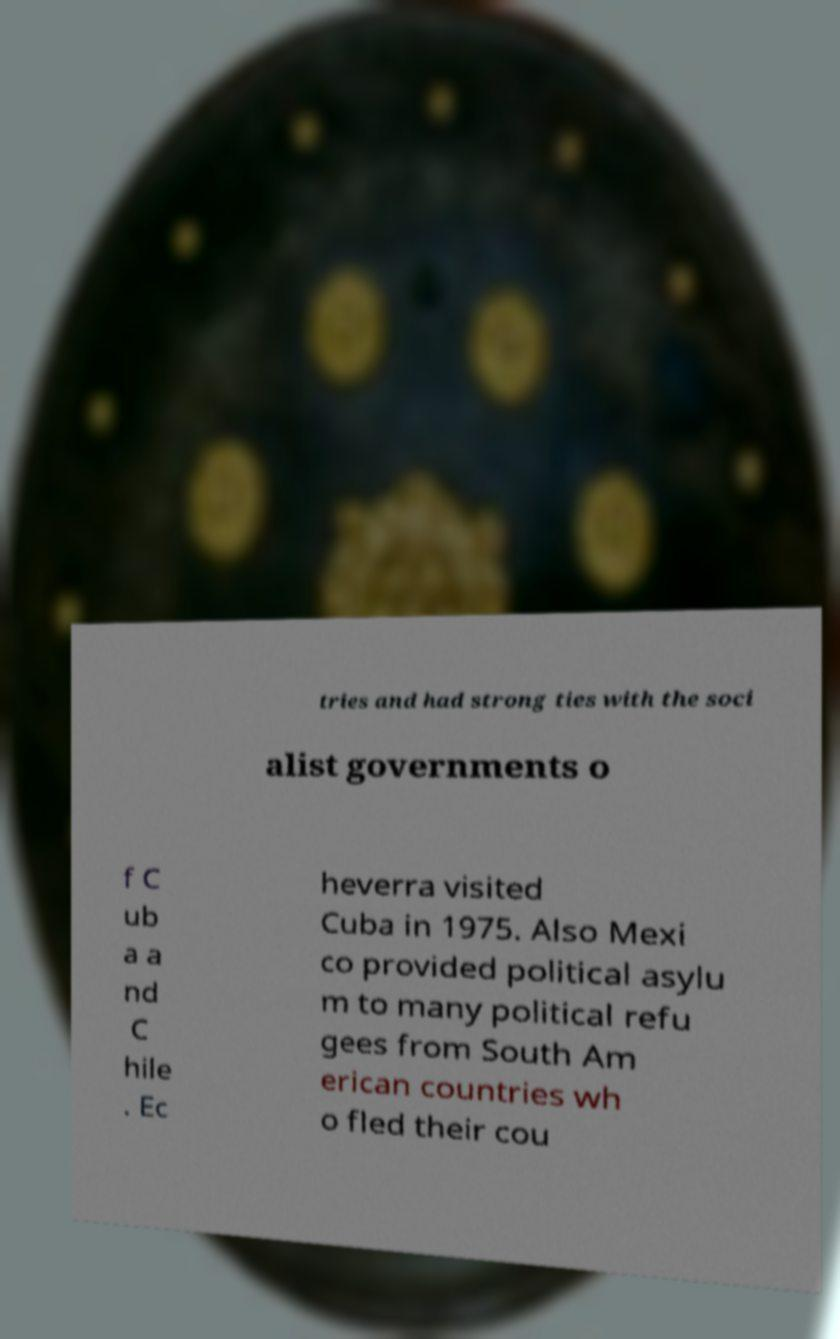What messages or text are displayed in this image? I need them in a readable, typed format. tries and had strong ties with the soci alist governments o f C ub a a nd C hile . Ec heverra visited Cuba in 1975. Also Mexi co provided political asylu m to many political refu gees from South Am erican countries wh o fled their cou 